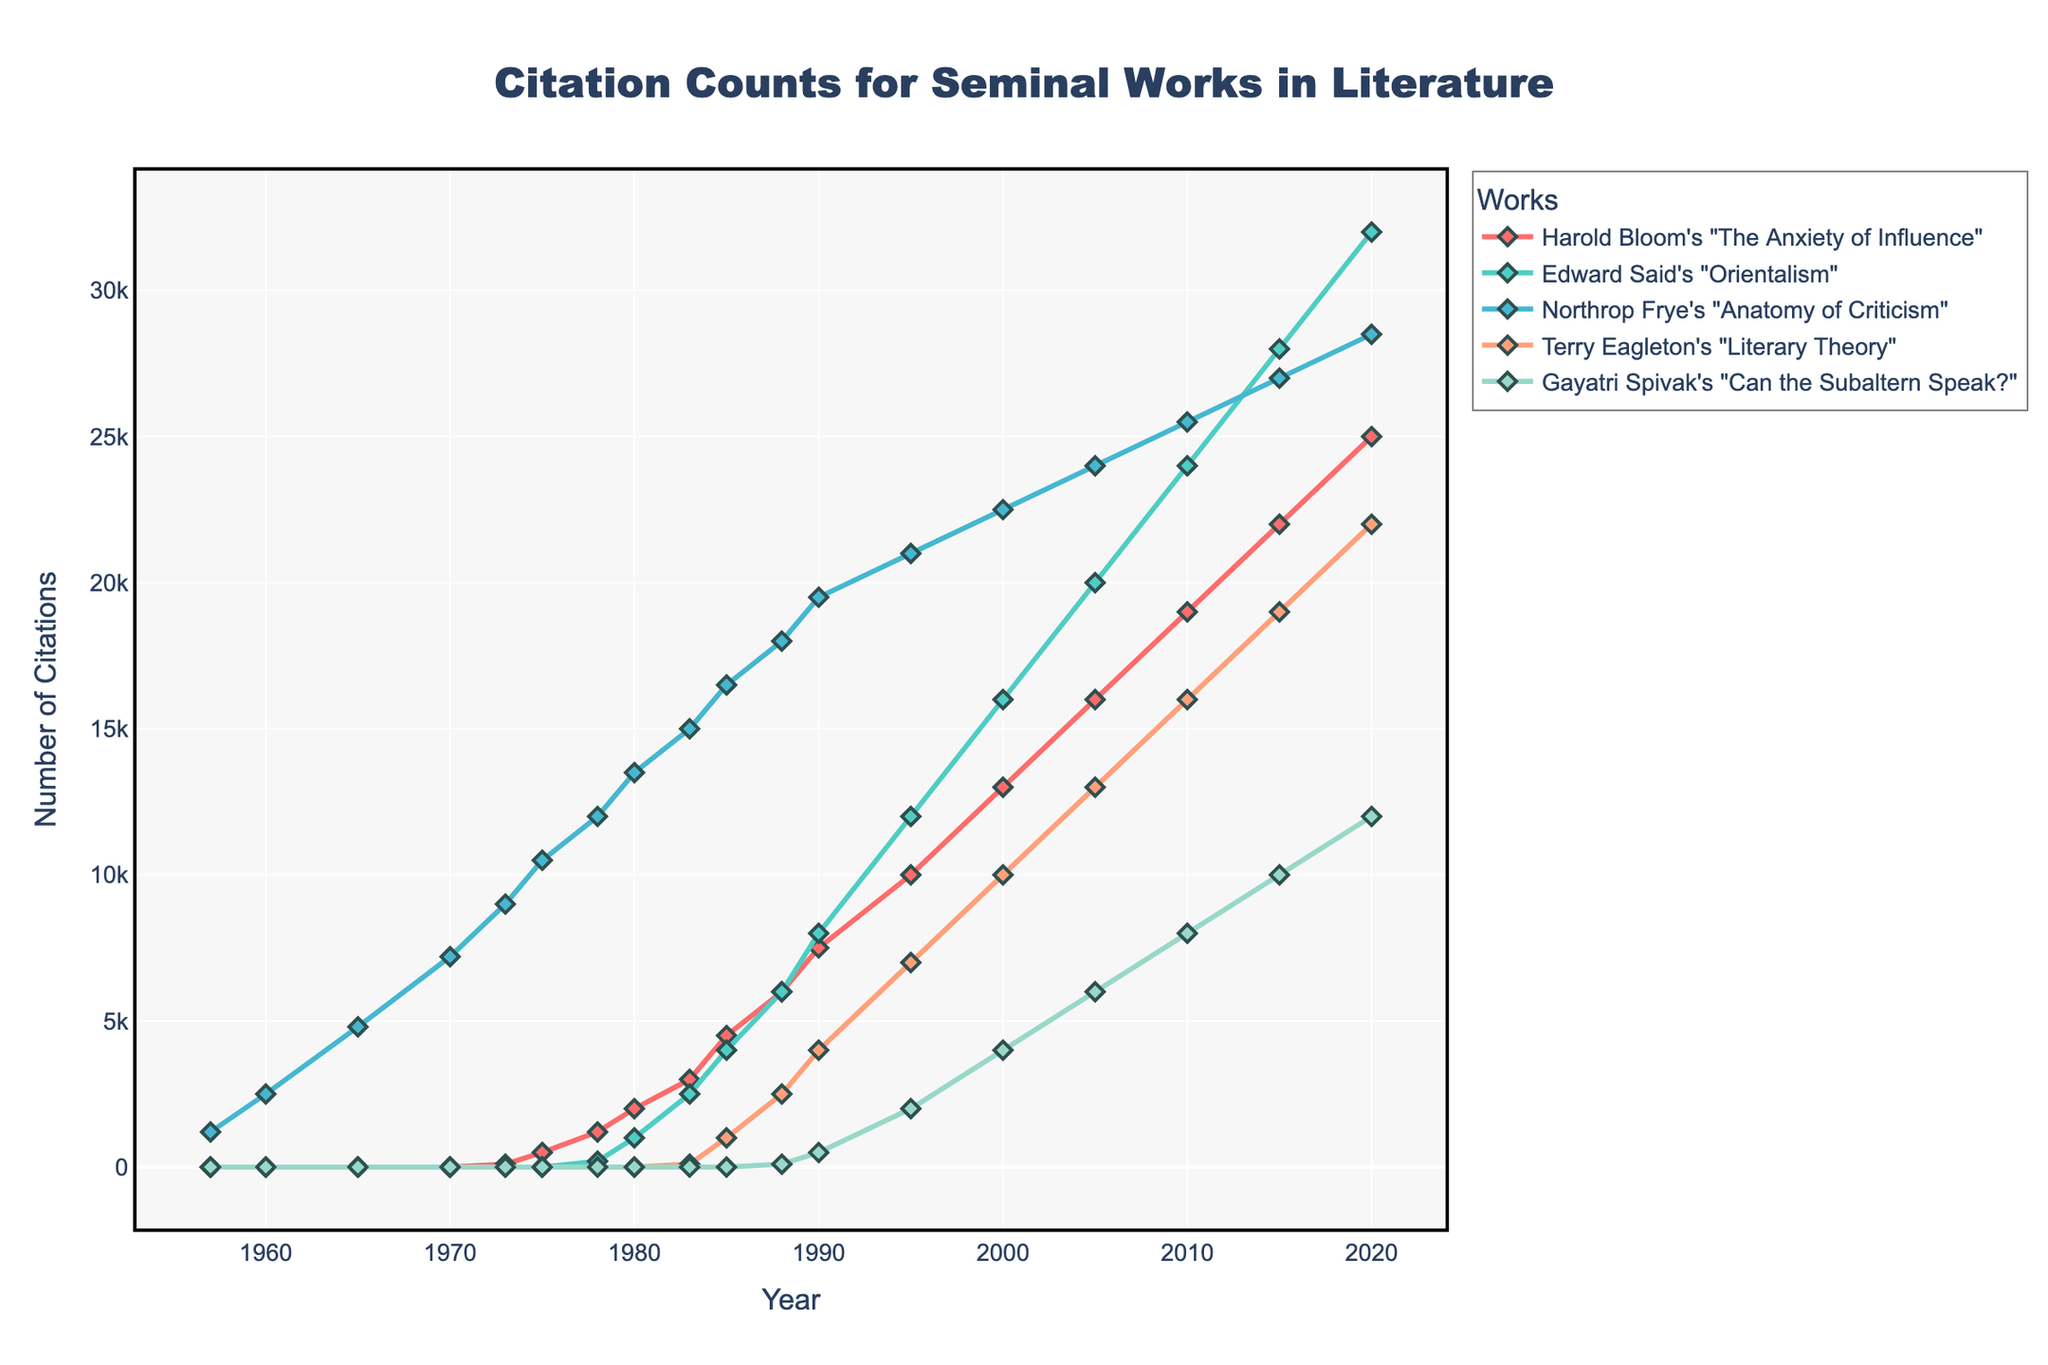What is the total number of citations for all works in the year 2020? To find the total citations for 2020, sum up the citations of all the works in that year: 25000 (Bloom) + 32000 (Said) + 28500 (Frye) + 22000 (Eagleton) + 12000 (Spivak) = 119500.
Answer: 119500 Which work had the highest number of citations in 1995? By examining the figure, we see that Edward Said's "Orientalism" had the highest citations in 1995 with 12000 citations.
Answer: Orientalism How did the citation count of Northrop Frye's "Anatomy of Criticism" change from 1960 to 2000? Calculate the difference between the citation count in 2000 and 1960: 22500 (2000) - 2500 (1960) = 20000.
Answer: Increase of 20000 Which work experienced the largest increase in citations between 1983 and 1990? Compare the citation count increases for each work: Bloom: 7500 - 3000 = 4500, Said: 8000 - 2500 = 5500, Frye: 19500 - 15000 = 4500, Eagleton: 4000 - 100 = 3900, Spivak: 500 - 0 = 500. Edward Said's "Orientalism" had the largest increase of 5500.
Answer: Orientalism What work reached 10000 citations first, and in which year? By following each citation line, Northrop Frye's "Anatomy of Criticism" first reached 10000 citations in 1973.
Answer: Anatomy of Criticism in 1973 Compare the citation trends of Gayatri Spivak's "Can the Subaltern Speak?" and Terry Eagleton's "Literary Theory" between 2000 and 2020. Eagleton's work increased from 10000 to 22000 citations, an increase of 12000, while Spivak's increased from 4000 to 12000, an increase of 8000. Eagleton's work had a greater increase.
Answer: Eagleton's increased more Which work had the least number of citations in 1988? Observing the lines for 1988 in the figure, Gayatri Spivak's "Can the Subaltern Speak?" had the least number of citations with 100 citations.
Answer: Can the Subaltern Speak? Did any work have exactly 15000 citations at any year? By checking the y-axis values, anatomy of criticism had exactly 15000 citations in 1983.
Answer: Anatomy of Criticism in 1983 